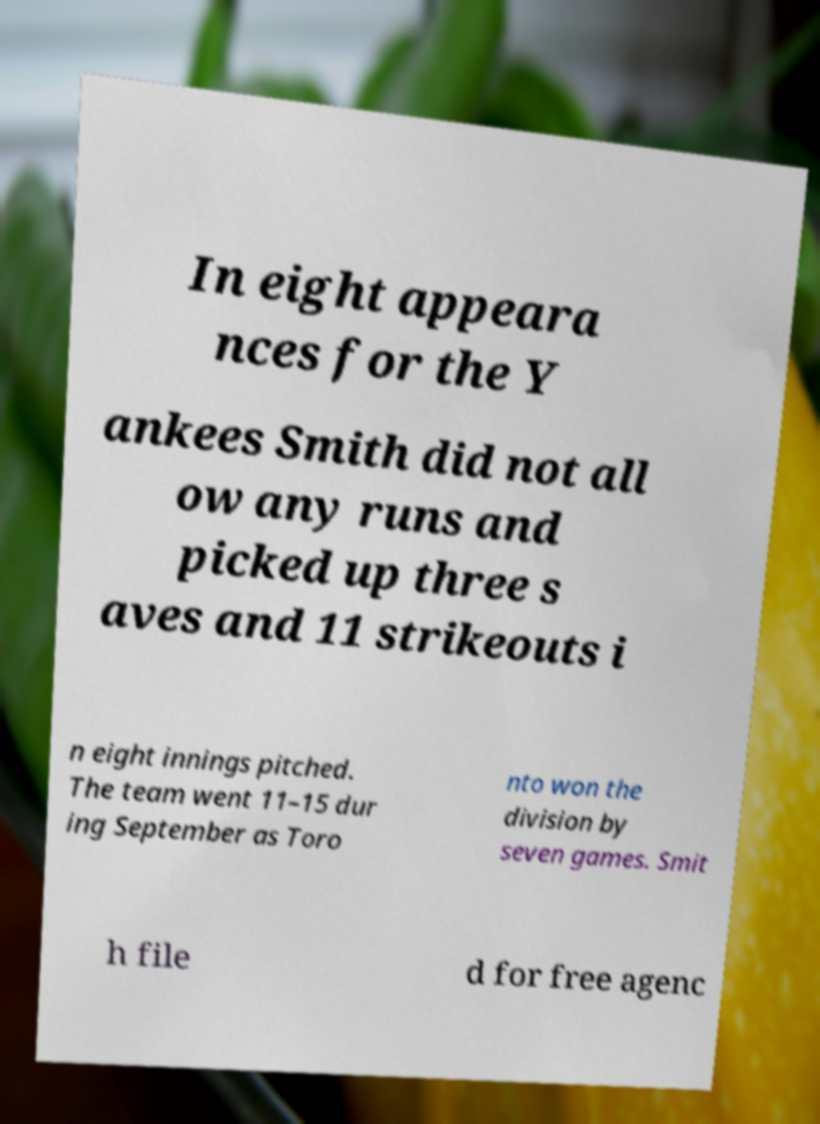Please identify and transcribe the text found in this image. In eight appeara nces for the Y ankees Smith did not all ow any runs and picked up three s aves and 11 strikeouts i n eight innings pitched. The team went 11–15 dur ing September as Toro nto won the division by seven games. Smit h file d for free agenc 